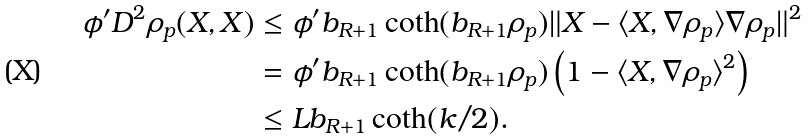Convert formula to latex. <formula><loc_0><loc_0><loc_500><loc_500>\phi ^ { \prime } D ^ { 2 } \rho _ { p } ( X , X ) & \leq \phi ^ { \prime } b _ { R + 1 } \coth ( b _ { R + 1 } \rho _ { p } ) \| X - \langle X , \nabla \rho _ { p } \rangle \nabla \rho _ { p } \| ^ { 2 } \\ & = \phi ^ { \prime } b _ { R + 1 } \coth ( b _ { R + 1 } \rho _ { p } ) \left ( 1 - \langle X , \nabla \rho _ { p } \rangle ^ { 2 } \right ) \\ & \leq L b _ { R + 1 } \coth ( k / 2 ) .</formula> 